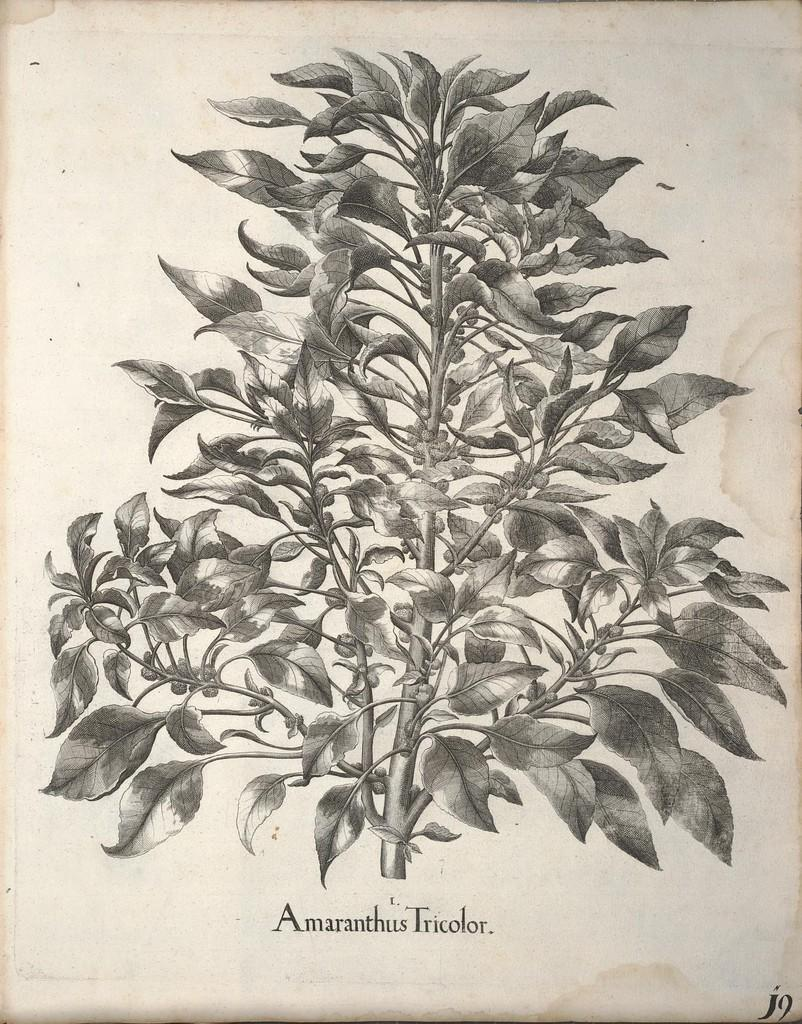What type of living organism can be seen in the image? There is a plant in the image. What else is present in the image besides the plant? There is text on paper in the image. What type of smoke can be seen coming from the plant in the image? There is no smoke present in the image; it features a plant and text on paper. 